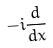Convert formula to latex. <formula><loc_0><loc_0><loc_500><loc_500>- i \frac { d } { d x }</formula> 